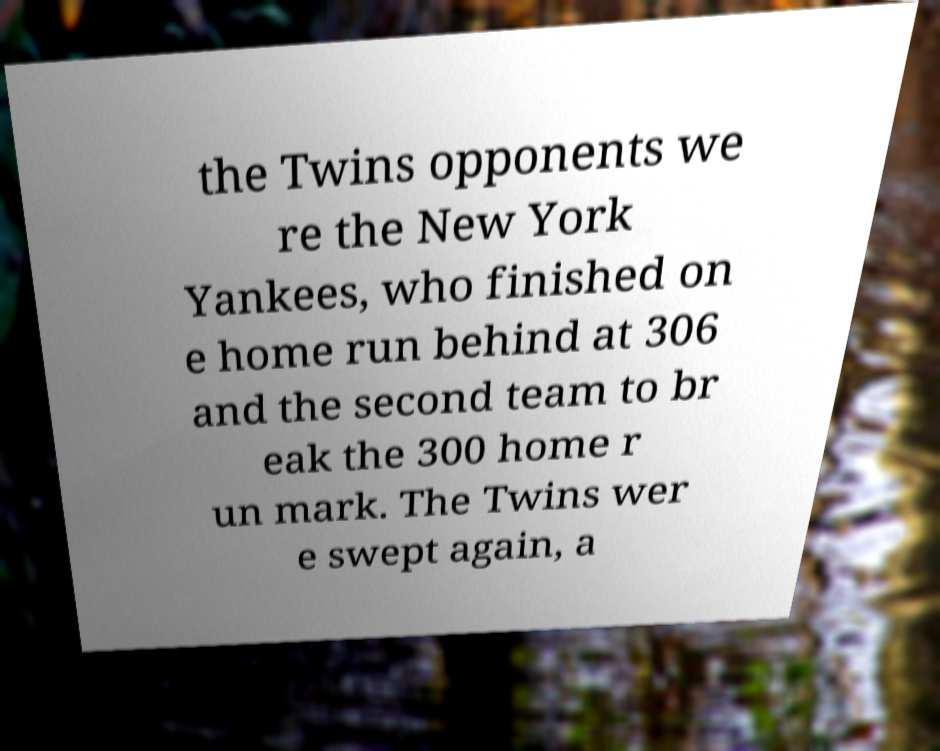For documentation purposes, I need the text within this image transcribed. Could you provide that? the Twins opponents we re the New York Yankees, who finished on e home run behind at 306 and the second team to br eak the 300 home r un mark. The Twins wer e swept again, a 